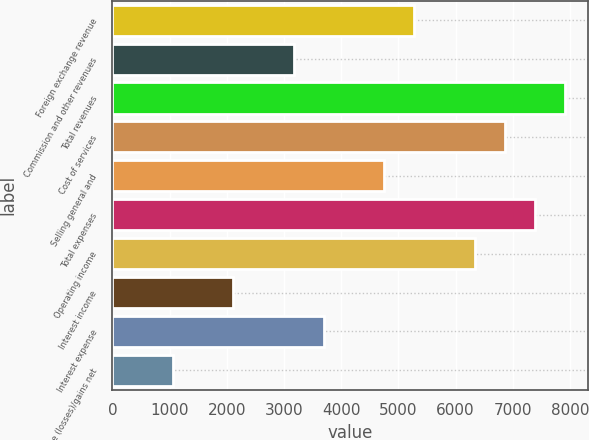<chart> <loc_0><loc_0><loc_500><loc_500><bar_chart><fcel>Foreign exchange revenue<fcel>Commission and other revenues<fcel>Total revenues<fcel>Cost of services<fcel>Selling general and<fcel>Total expenses<fcel>Operating income<fcel>Interest income<fcel>Interest expense<fcel>Derivative (losses)/gains net<nl><fcel>5282.04<fcel>3169.72<fcel>7922.44<fcel>6866.28<fcel>4753.96<fcel>7394.36<fcel>6338.2<fcel>2113.56<fcel>3697.8<fcel>1057.4<nl></chart> 